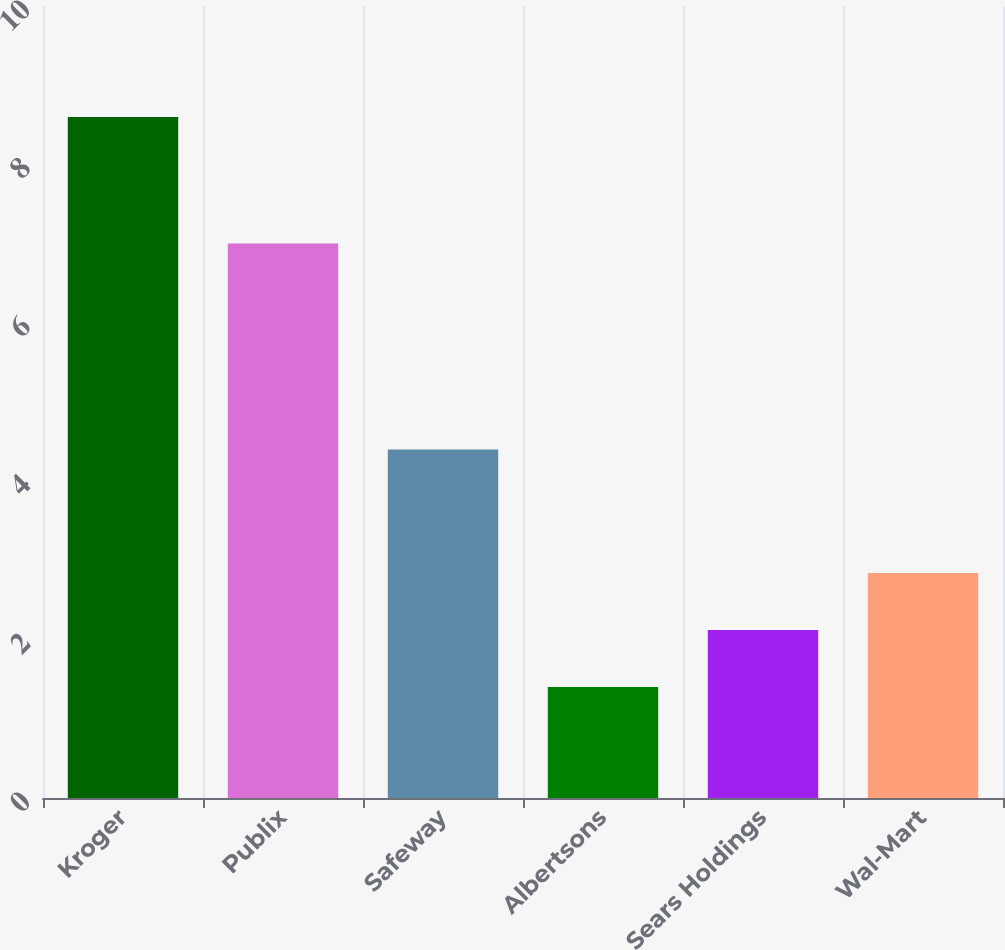Convert chart to OTSL. <chart><loc_0><loc_0><loc_500><loc_500><bar_chart><fcel>Kroger<fcel>Publix<fcel>Safeway<fcel>Albertsons<fcel>Sears Holdings<fcel>Wal-Mart<nl><fcel>8.6<fcel>7<fcel>4.4<fcel>1.4<fcel>2.12<fcel>2.84<nl></chart> 